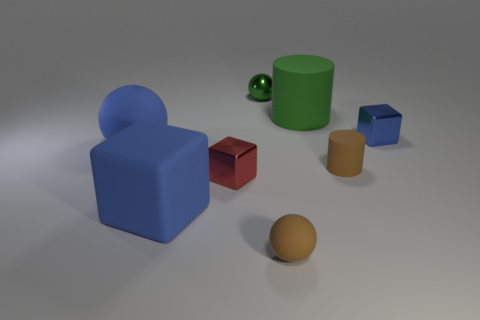Do the green rubber cylinder and the blue shiny cube have the same size?
Make the answer very short. No. There is a red thing to the left of the tiny block that is to the right of the small green metallic thing; what size is it?
Ensure brevity in your answer.  Small. There is a small thing that is the same color as the tiny rubber cylinder; what shape is it?
Your answer should be very brief. Sphere. What number of spheres are small red objects or large green rubber objects?
Offer a very short reply. 0. Is the size of the green shiny sphere the same as the rubber cylinder that is behind the blue sphere?
Provide a succinct answer. No. Are there more cylinders right of the tiny brown rubber cylinder than blue objects?
Your answer should be very brief. No. What size is the green object that is made of the same material as the brown ball?
Provide a short and direct response. Large. Is there another metal ball that has the same color as the big sphere?
Ensure brevity in your answer.  No. How many things are either small purple rubber objects or blocks that are in front of the big rubber sphere?
Your answer should be compact. 2. Is the number of green metallic balls greater than the number of purple cubes?
Offer a terse response. Yes. 